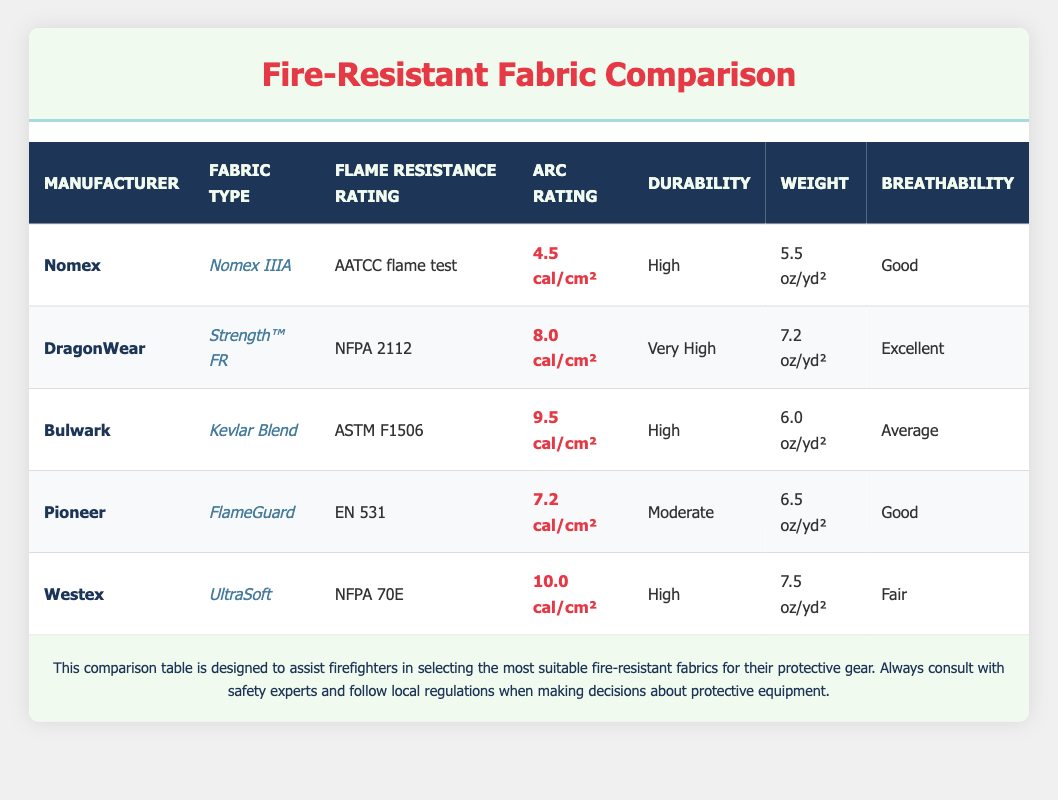What is the flame resistance rating of the fabric from DragonWear? According to the table, the fabric from DragonWear, known as Strength™ FR, has a flame resistance rating of NFPA 2112.
Answer: NFPA 2112 Which manufacturer offers a fabric with the highest arc rating? In the table, Westex's UltraSoft has the highest arc rating at 10.0 cal/cm², as compared to the other manufacturers' fabrics.
Answer: Westex What is the average weight of the fire-resistant fabrics listed in the table? The weights are 5.5, 7.2, 6.0, 6.5, and 7.5 oz/yd². Summing these gives 5.5 + 7.2 + 6.0 + 6.5 + 7.5 = 32.7. Dividing by 5 (the total number of fabrics), the average weight is 32.7 / 5 = 6.54 oz/yd².
Answer: 6.54 oz/yd² Is the breathability rating of Bulwark's fabric average? The table shows that Bulwark's Kevlar Blend has an average breathability rating. Therefore, the statement is true.
Answer: Yes What is the difference in arc rating between the highest and lowest-rated fabrics? The highest arc rating is from Westex at 10.0 cal/cm² and the lowest rating is from Nomex at 4.5 cal/cm². The difference is 10.0 - 4.5 = 5.5 cal/cm².
Answer: 5.5 cal/cm² Which fabric has a durability rating of "Very High"? From the table, the fabric with a durability rating of "Very High" is DragonWear’s Strength™ FR.
Answer: DragonWear Are there any fabrics with a breathability rating categorized as "Excellent"? The table shows that DragonWear’s fabric has an excellent breathability rating, thus the statement is true.
Answer: Yes How many manufacturers have fabrics weighing more than 6 oz/yd²? The weights over 6 oz/yd² are 7.2 oz/yd² (DragonWear), 7.5 oz/yd² (Westex), leading to a total of 2 manufacturers meeting this criterion.
Answer: 2 